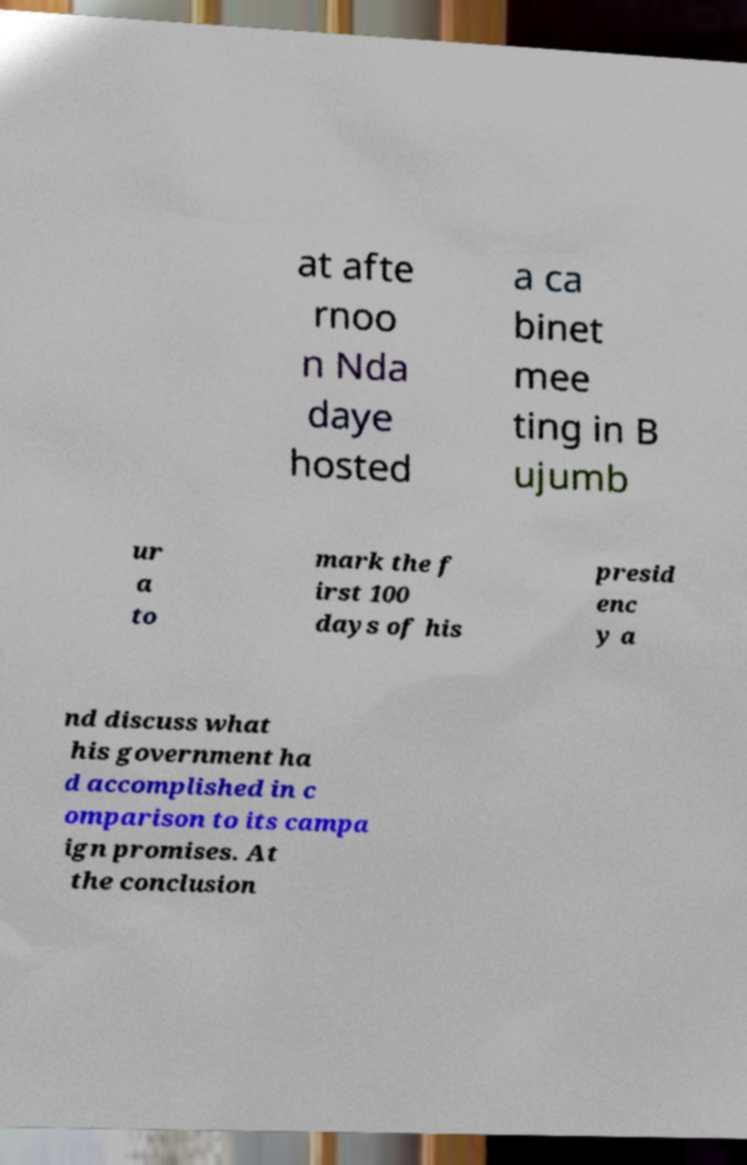Could you extract and type out the text from this image? at afte rnoo n Nda daye hosted a ca binet mee ting in B ujumb ur a to mark the f irst 100 days of his presid enc y a nd discuss what his government ha d accomplished in c omparison to its campa ign promises. At the conclusion 